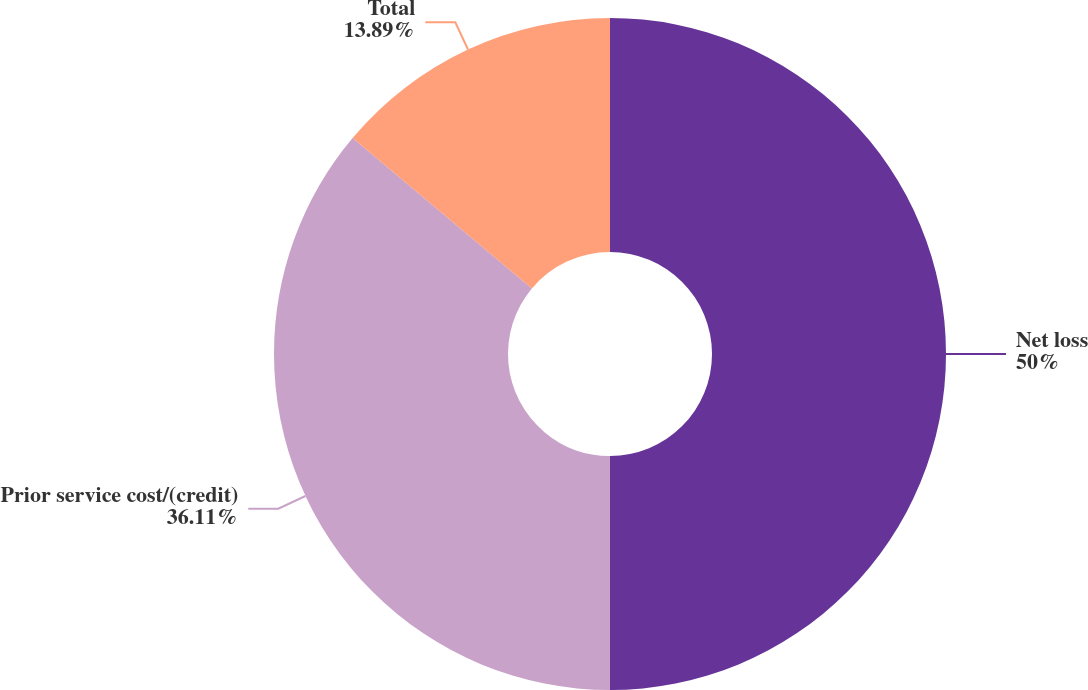Convert chart. <chart><loc_0><loc_0><loc_500><loc_500><pie_chart><fcel>Net loss<fcel>Prior service cost/(credit)<fcel>Total<nl><fcel>50.0%<fcel>36.11%<fcel>13.89%<nl></chart> 